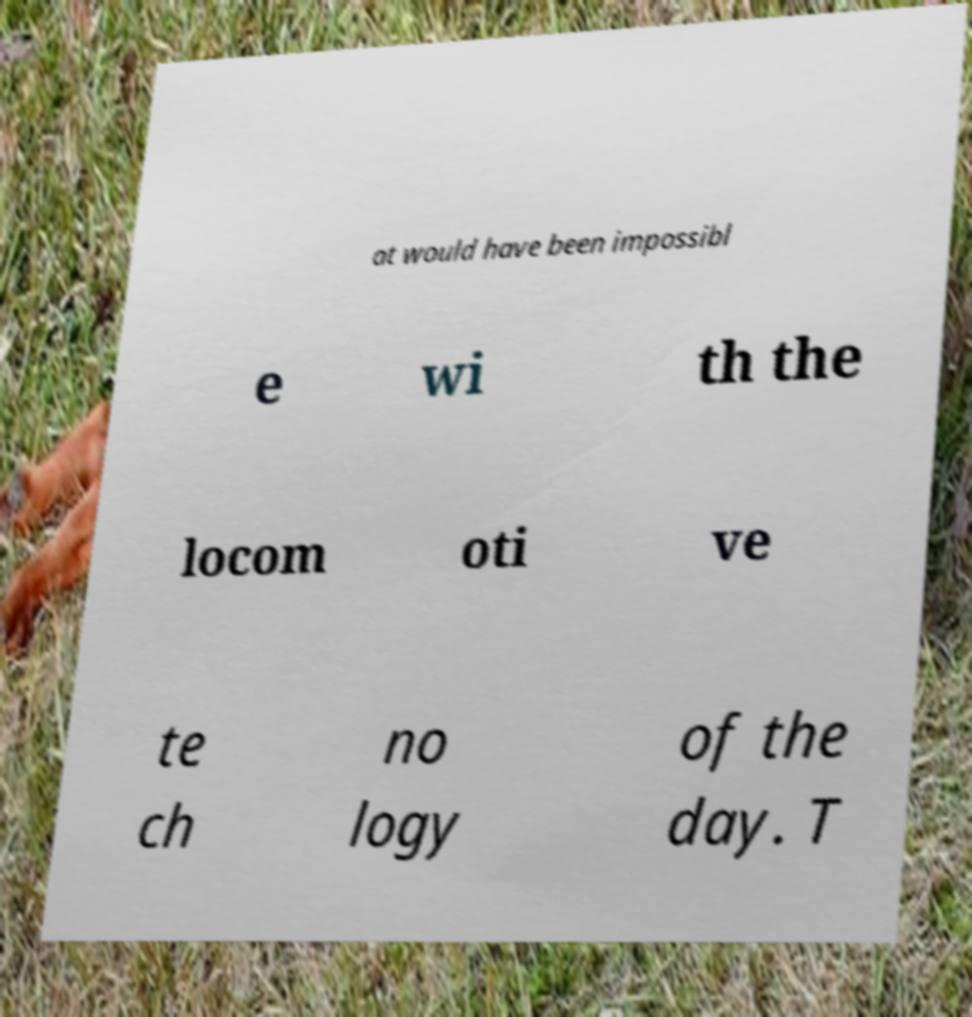Could you assist in decoding the text presented in this image and type it out clearly? at would have been impossibl e wi th the locom oti ve te ch no logy of the day. T 